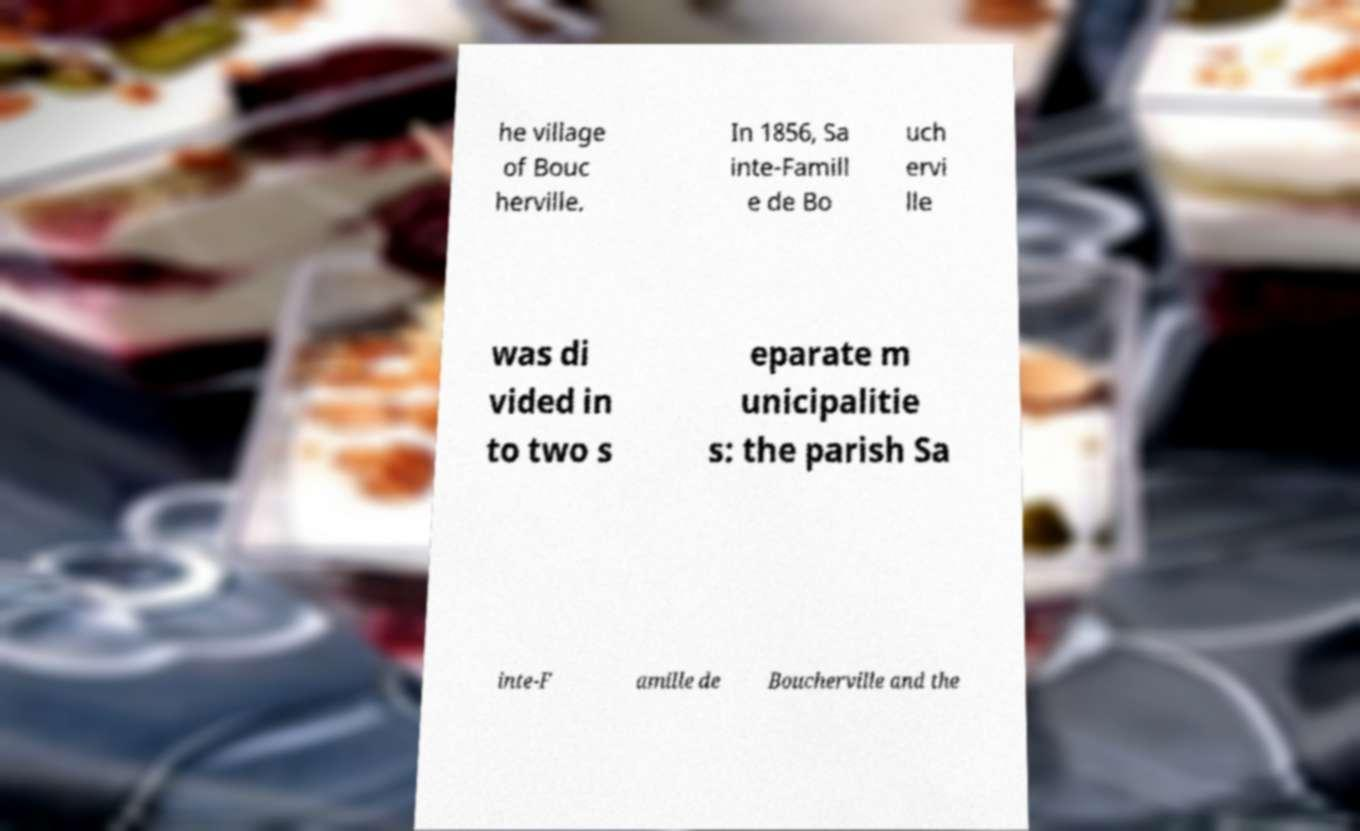Could you assist in decoding the text presented in this image and type it out clearly? he village of Bouc herville. In 1856, Sa inte-Famill e de Bo uch ervi lle was di vided in to two s eparate m unicipalitie s: the parish Sa inte-F amille de Boucherville and the 